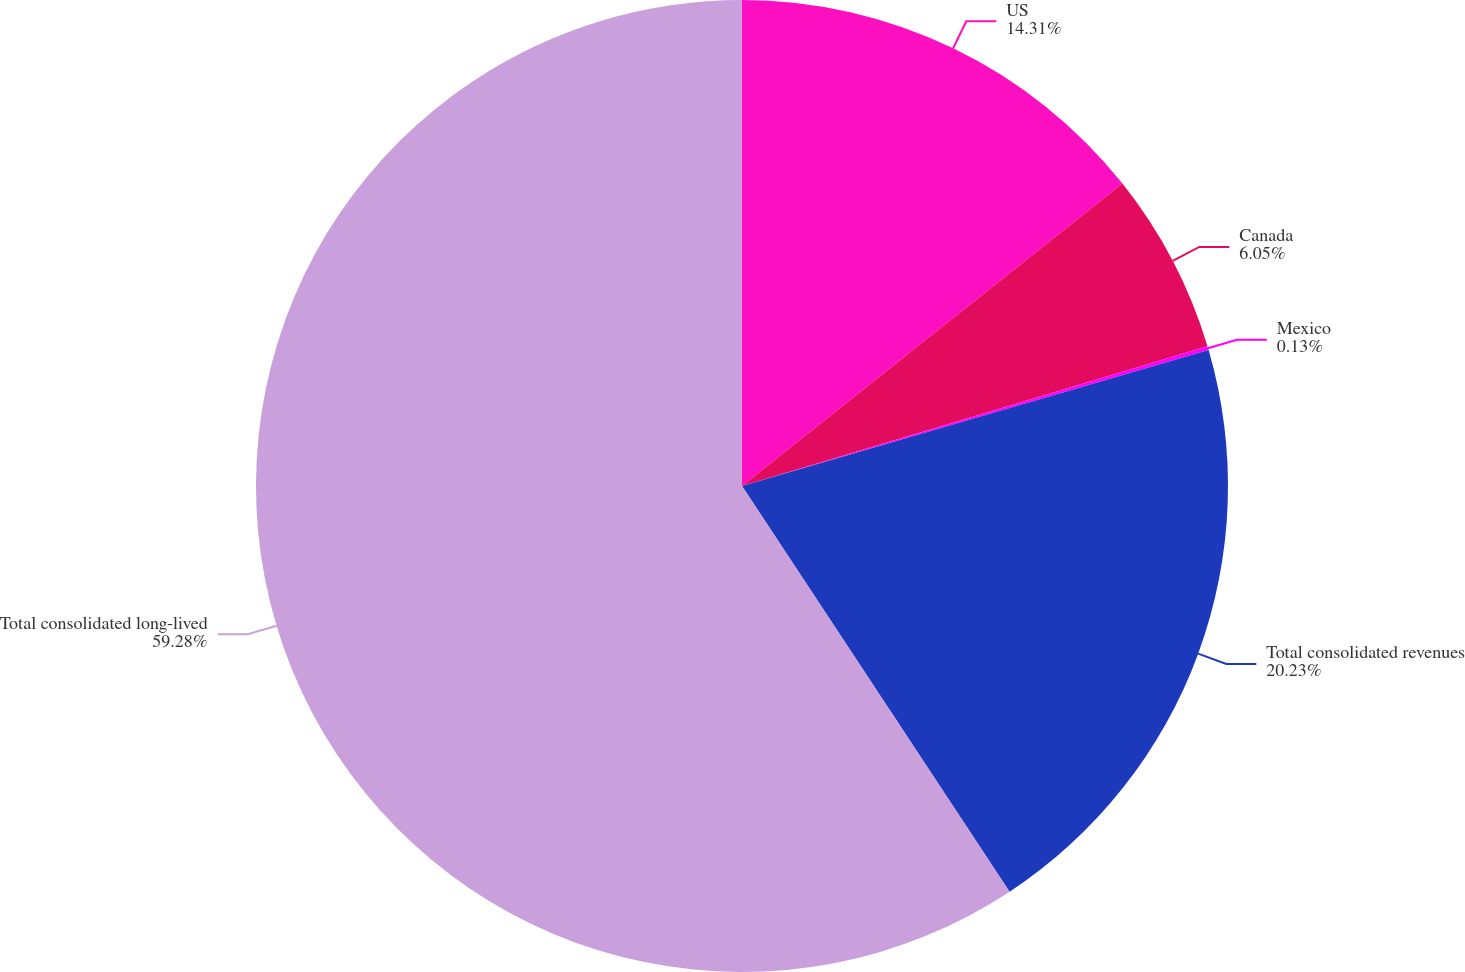Convert chart to OTSL. <chart><loc_0><loc_0><loc_500><loc_500><pie_chart><fcel>US<fcel>Canada<fcel>Mexico<fcel>Total consolidated revenues<fcel>Total consolidated long-lived<nl><fcel>14.31%<fcel>6.05%<fcel>0.13%<fcel>20.23%<fcel>59.28%<nl></chart> 